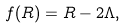<formula> <loc_0><loc_0><loc_500><loc_500>f ( R ) = R - 2 \Lambda ,</formula> 